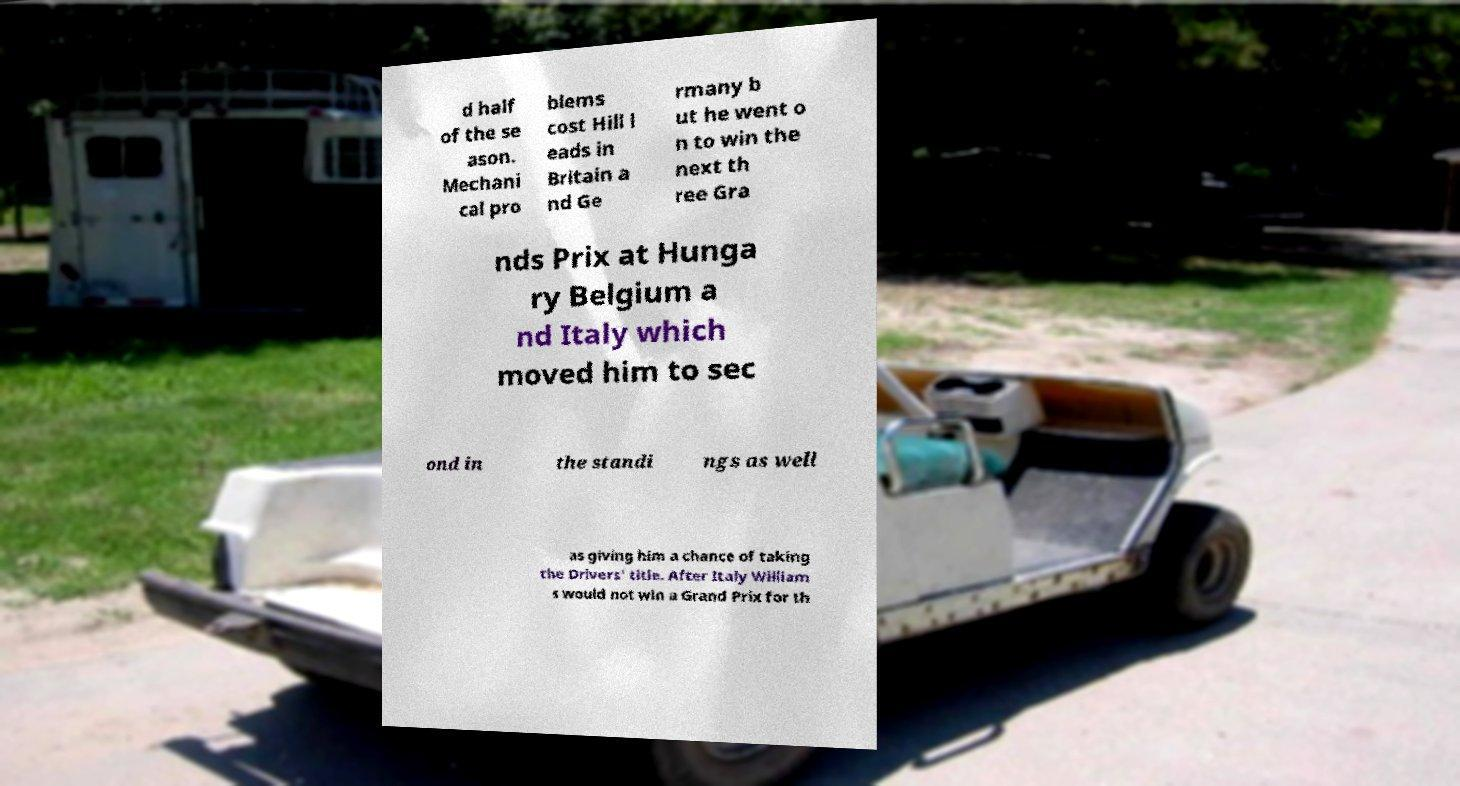I need the written content from this picture converted into text. Can you do that? d half of the se ason. Mechani cal pro blems cost Hill l eads in Britain a nd Ge rmany b ut he went o n to win the next th ree Gra nds Prix at Hunga ry Belgium a nd Italy which moved him to sec ond in the standi ngs as well as giving him a chance of taking the Drivers' title. After Italy William s would not win a Grand Prix for th 